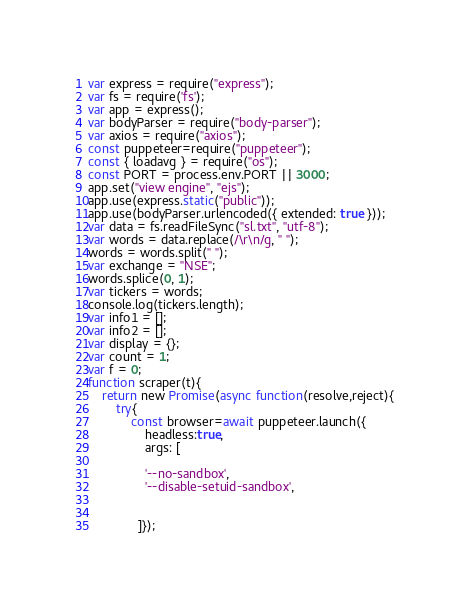<code> <loc_0><loc_0><loc_500><loc_500><_JavaScript_>var express = require("express");
var fs = require('fs');
var app = express();
var bodyParser = require("body-parser");
var axios = require("axios");
const puppeteer=require("puppeteer");
const { loadavg } = require("os");
const PORT = process.env.PORT || 3000;
app.set("view engine", "ejs");
app.use(express.static("public"));
app.use(bodyParser.urlencoded({ extended: true }));
var data = fs.readFileSync("sl.txt", "utf-8");
var words = data.replace(/\r\n/g, " ");
words = words.split(" ");
var exchange = "NSE";
words.splice(0, 1);
var tickers = words;
console.log(tickers.length);
var info1 = [];
var info2 = [];
var display = {};
var count = 1;
var f = 0;
function scraper(t){
    return new Promise(async function(resolve,reject){
        try{
            const browser=await puppeteer.launch({
                headless:true,
                args: [
                
                '--no-sandbox',
                '--disable-setuid-sandbox',
                

              ]});</code> 